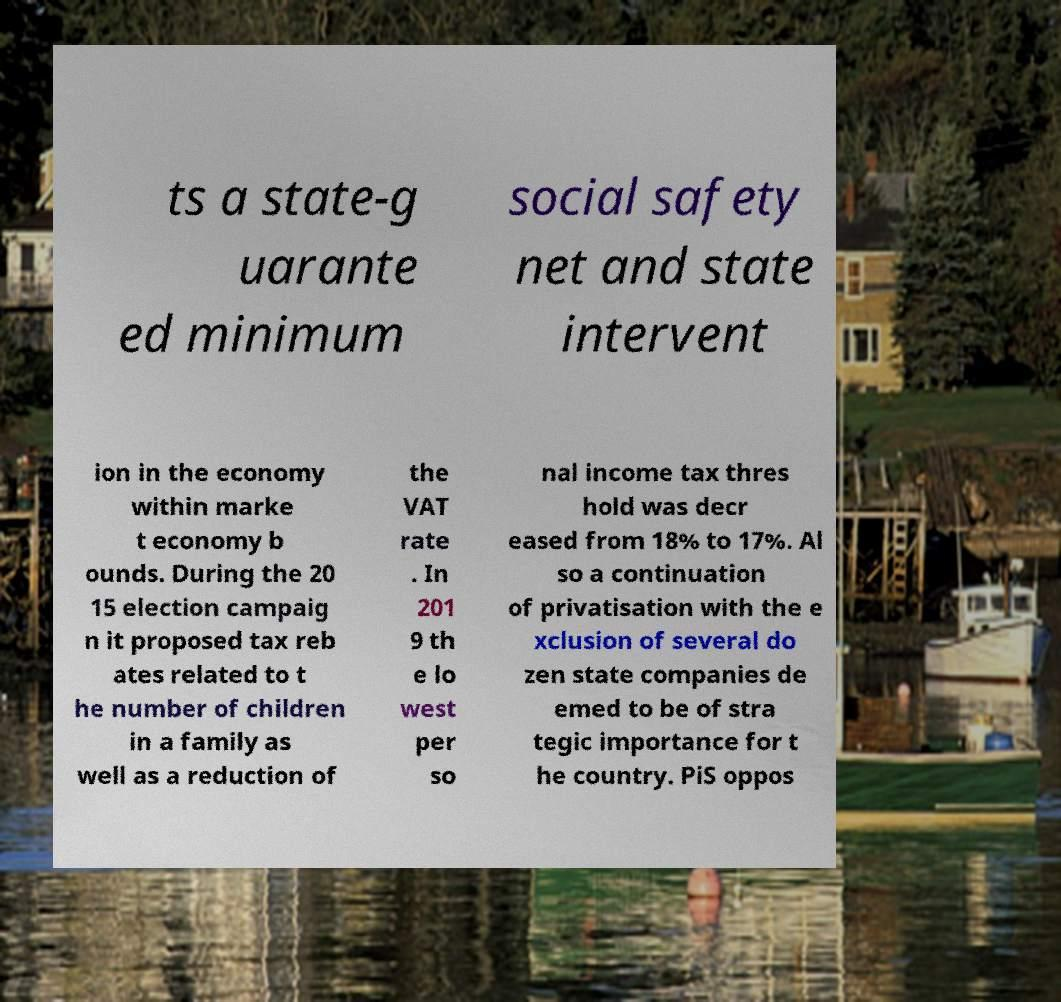Please identify and transcribe the text found in this image. ts a state-g uarante ed minimum social safety net and state intervent ion in the economy within marke t economy b ounds. During the 20 15 election campaig n it proposed tax reb ates related to t he number of children in a family as well as a reduction of the VAT rate . In 201 9 th e lo west per so nal income tax thres hold was decr eased from 18% to 17%. Al so a continuation of privatisation with the e xclusion of several do zen state companies de emed to be of stra tegic importance for t he country. PiS oppos 